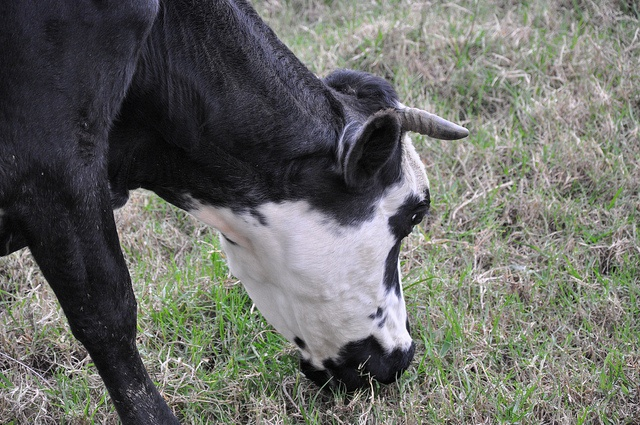Describe the objects in this image and their specific colors. I can see a cow in black, darkgray, gray, and lavender tones in this image. 